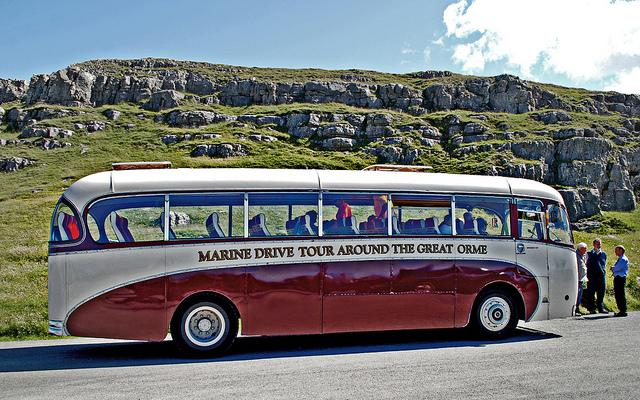What is the bus primarily used for? touring 